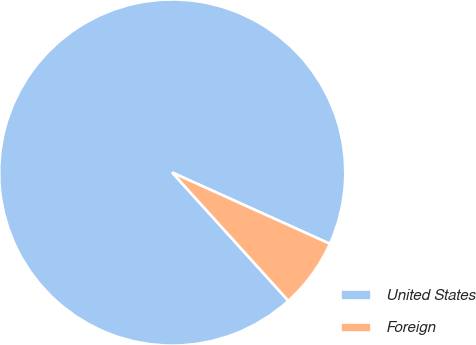<chart> <loc_0><loc_0><loc_500><loc_500><pie_chart><fcel>United States<fcel>Foreign<nl><fcel>93.47%<fcel>6.53%<nl></chart> 